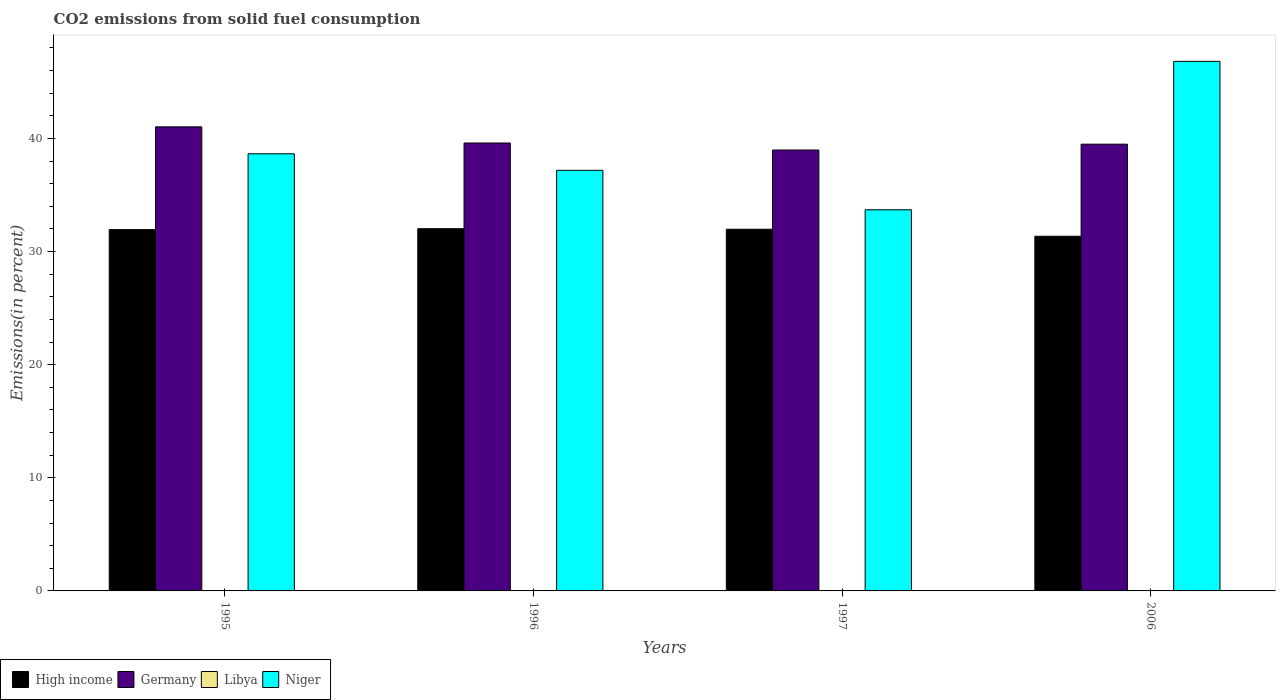How many different coloured bars are there?
Your response must be concise. 4. Are the number of bars on each tick of the X-axis equal?
Make the answer very short. Yes. How many bars are there on the 3rd tick from the left?
Give a very brief answer. 4. How many bars are there on the 3rd tick from the right?
Give a very brief answer. 4. In how many cases, is the number of bars for a given year not equal to the number of legend labels?
Offer a very short reply. 0. What is the total CO2 emitted in Niger in 1997?
Your response must be concise. 33.7. Across all years, what is the maximum total CO2 emitted in Niger?
Your answer should be compact. 46.82. Across all years, what is the minimum total CO2 emitted in Libya?
Make the answer very short. 0.01. What is the total total CO2 emitted in Libya in the graph?
Give a very brief answer. 0.1. What is the difference between the total CO2 emitted in Niger in 1997 and that in 2006?
Provide a succinct answer. -13.12. What is the difference between the total CO2 emitted in Niger in 2006 and the total CO2 emitted in Libya in 1995?
Make the answer very short. 46.79. What is the average total CO2 emitted in Germany per year?
Your response must be concise. 39.78. In the year 1996, what is the difference between the total CO2 emitted in Niger and total CO2 emitted in Germany?
Provide a short and direct response. -2.42. What is the ratio of the total CO2 emitted in High income in 1997 to that in 2006?
Ensure brevity in your answer.  1.02. Is the difference between the total CO2 emitted in Niger in 1995 and 1997 greater than the difference between the total CO2 emitted in Germany in 1995 and 1997?
Your answer should be very brief. Yes. What is the difference between the highest and the second highest total CO2 emitted in High income?
Offer a terse response. 0.05. What is the difference between the highest and the lowest total CO2 emitted in Libya?
Your answer should be very brief. 0.03. In how many years, is the total CO2 emitted in Germany greater than the average total CO2 emitted in Germany taken over all years?
Keep it short and to the point. 1. Is it the case that in every year, the sum of the total CO2 emitted in Libya and total CO2 emitted in High income is greater than the sum of total CO2 emitted in Niger and total CO2 emitted in Germany?
Make the answer very short. No. What does the 4th bar from the left in 1995 represents?
Offer a very short reply. Niger. How many bars are there?
Your answer should be very brief. 16. How many years are there in the graph?
Your answer should be compact. 4. What is the difference between two consecutive major ticks on the Y-axis?
Offer a terse response. 10. Where does the legend appear in the graph?
Provide a succinct answer. Bottom left. What is the title of the graph?
Provide a short and direct response. CO2 emissions from solid fuel consumption. What is the label or title of the X-axis?
Provide a short and direct response. Years. What is the label or title of the Y-axis?
Keep it short and to the point. Emissions(in percent). What is the Emissions(in percent) of High income in 1995?
Offer a very short reply. 31.94. What is the Emissions(in percent) of Germany in 1995?
Your answer should be compact. 41.03. What is the Emissions(in percent) in Libya in 1995?
Offer a very short reply. 0.03. What is the Emissions(in percent) in Niger in 1995?
Provide a succinct answer. 38.65. What is the Emissions(in percent) of High income in 1996?
Offer a very short reply. 32.02. What is the Emissions(in percent) of Germany in 1996?
Provide a short and direct response. 39.6. What is the Emissions(in percent) in Libya in 1996?
Your response must be concise. 0.03. What is the Emissions(in percent) of Niger in 1996?
Keep it short and to the point. 37.18. What is the Emissions(in percent) of High income in 1997?
Ensure brevity in your answer.  31.98. What is the Emissions(in percent) in Germany in 1997?
Offer a terse response. 38.98. What is the Emissions(in percent) in Libya in 1997?
Ensure brevity in your answer.  0.03. What is the Emissions(in percent) in Niger in 1997?
Offer a terse response. 33.7. What is the Emissions(in percent) in High income in 2006?
Give a very brief answer. 31.35. What is the Emissions(in percent) of Germany in 2006?
Keep it short and to the point. 39.5. What is the Emissions(in percent) of Libya in 2006?
Your answer should be compact. 0.01. What is the Emissions(in percent) in Niger in 2006?
Your response must be concise. 46.82. Across all years, what is the maximum Emissions(in percent) of High income?
Provide a short and direct response. 32.02. Across all years, what is the maximum Emissions(in percent) of Germany?
Offer a terse response. 41.03. Across all years, what is the maximum Emissions(in percent) in Libya?
Keep it short and to the point. 0.03. Across all years, what is the maximum Emissions(in percent) of Niger?
Offer a terse response. 46.82. Across all years, what is the minimum Emissions(in percent) in High income?
Offer a terse response. 31.35. Across all years, what is the minimum Emissions(in percent) of Germany?
Provide a succinct answer. 38.98. Across all years, what is the minimum Emissions(in percent) in Libya?
Your answer should be compact. 0.01. Across all years, what is the minimum Emissions(in percent) in Niger?
Your answer should be compact. 33.7. What is the total Emissions(in percent) of High income in the graph?
Make the answer very short. 127.3. What is the total Emissions(in percent) in Germany in the graph?
Provide a succinct answer. 159.1. What is the total Emissions(in percent) of Libya in the graph?
Provide a short and direct response. 0.1. What is the total Emissions(in percent) of Niger in the graph?
Give a very brief answer. 156.34. What is the difference between the Emissions(in percent) in High income in 1995 and that in 1996?
Offer a very short reply. -0.08. What is the difference between the Emissions(in percent) in Germany in 1995 and that in 1996?
Provide a short and direct response. 1.43. What is the difference between the Emissions(in percent) of Libya in 1995 and that in 1996?
Give a very brief answer. -0. What is the difference between the Emissions(in percent) in Niger in 1995 and that in 1996?
Your answer should be very brief. 1.46. What is the difference between the Emissions(in percent) in High income in 1995 and that in 1997?
Your answer should be very brief. -0.03. What is the difference between the Emissions(in percent) in Germany in 1995 and that in 1997?
Ensure brevity in your answer.  2.05. What is the difference between the Emissions(in percent) of Libya in 1995 and that in 1997?
Keep it short and to the point. -0. What is the difference between the Emissions(in percent) in Niger in 1995 and that in 1997?
Keep it short and to the point. 4.95. What is the difference between the Emissions(in percent) of High income in 1995 and that in 2006?
Your answer should be very brief. 0.59. What is the difference between the Emissions(in percent) in Germany in 1995 and that in 2006?
Provide a succinct answer. 1.53. What is the difference between the Emissions(in percent) of Libya in 1995 and that in 2006?
Offer a very short reply. 0.03. What is the difference between the Emissions(in percent) in Niger in 1995 and that in 2006?
Provide a succinct answer. -8.17. What is the difference between the Emissions(in percent) of High income in 1996 and that in 1997?
Offer a terse response. 0.05. What is the difference between the Emissions(in percent) in Germany in 1996 and that in 1997?
Make the answer very short. 0.62. What is the difference between the Emissions(in percent) in Libya in 1996 and that in 1997?
Make the answer very short. 0. What is the difference between the Emissions(in percent) in Niger in 1996 and that in 1997?
Your answer should be compact. 3.49. What is the difference between the Emissions(in percent) in High income in 1996 and that in 2006?
Give a very brief answer. 0.67. What is the difference between the Emissions(in percent) in Germany in 1996 and that in 2006?
Offer a terse response. 0.1. What is the difference between the Emissions(in percent) in Libya in 1996 and that in 2006?
Your response must be concise. 0.03. What is the difference between the Emissions(in percent) of Niger in 1996 and that in 2006?
Provide a succinct answer. -9.63. What is the difference between the Emissions(in percent) of High income in 1997 and that in 2006?
Offer a terse response. 0.62. What is the difference between the Emissions(in percent) of Germany in 1997 and that in 2006?
Keep it short and to the point. -0.52. What is the difference between the Emissions(in percent) of Libya in 1997 and that in 2006?
Offer a terse response. 0.03. What is the difference between the Emissions(in percent) in Niger in 1997 and that in 2006?
Make the answer very short. -13.12. What is the difference between the Emissions(in percent) in High income in 1995 and the Emissions(in percent) in Germany in 1996?
Give a very brief answer. -7.66. What is the difference between the Emissions(in percent) of High income in 1995 and the Emissions(in percent) of Libya in 1996?
Provide a succinct answer. 31.91. What is the difference between the Emissions(in percent) in High income in 1995 and the Emissions(in percent) in Niger in 1996?
Provide a short and direct response. -5.24. What is the difference between the Emissions(in percent) of Germany in 1995 and the Emissions(in percent) of Libya in 1996?
Provide a succinct answer. 40.99. What is the difference between the Emissions(in percent) of Germany in 1995 and the Emissions(in percent) of Niger in 1996?
Ensure brevity in your answer.  3.84. What is the difference between the Emissions(in percent) in Libya in 1995 and the Emissions(in percent) in Niger in 1996?
Give a very brief answer. -37.15. What is the difference between the Emissions(in percent) in High income in 1995 and the Emissions(in percent) in Germany in 1997?
Make the answer very short. -7.04. What is the difference between the Emissions(in percent) in High income in 1995 and the Emissions(in percent) in Libya in 1997?
Make the answer very short. 31.91. What is the difference between the Emissions(in percent) in High income in 1995 and the Emissions(in percent) in Niger in 1997?
Provide a short and direct response. -1.75. What is the difference between the Emissions(in percent) in Germany in 1995 and the Emissions(in percent) in Libya in 1997?
Ensure brevity in your answer.  41. What is the difference between the Emissions(in percent) of Germany in 1995 and the Emissions(in percent) of Niger in 1997?
Offer a very short reply. 7.33. What is the difference between the Emissions(in percent) of Libya in 1995 and the Emissions(in percent) of Niger in 1997?
Offer a very short reply. -33.66. What is the difference between the Emissions(in percent) in High income in 1995 and the Emissions(in percent) in Germany in 2006?
Your response must be concise. -7.55. What is the difference between the Emissions(in percent) of High income in 1995 and the Emissions(in percent) of Libya in 2006?
Your response must be concise. 31.94. What is the difference between the Emissions(in percent) in High income in 1995 and the Emissions(in percent) in Niger in 2006?
Your answer should be compact. -14.87. What is the difference between the Emissions(in percent) of Germany in 1995 and the Emissions(in percent) of Libya in 2006?
Offer a terse response. 41.02. What is the difference between the Emissions(in percent) in Germany in 1995 and the Emissions(in percent) in Niger in 2006?
Give a very brief answer. -5.79. What is the difference between the Emissions(in percent) in Libya in 1995 and the Emissions(in percent) in Niger in 2006?
Give a very brief answer. -46.79. What is the difference between the Emissions(in percent) in High income in 1996 and the Emissions(in percent) in Germany in 1997?
Your response must be concise. -6.96. What is the difference between the Emissions(in percent) in High income in 1996 and the Emissions(in percent) in Libya in 1997?
Provide a succinct answer. 31.99. What is the difference between the Emissions(in percent) in High income in 1996 and the Emissions(in percent) in Niger in 1997?
Offer a terse response. -1.67. What is the difference between the Emissions(in percent) in Germany in 1996 and the Emissions(in percent) in Libya in 1997?
Your response must be concise. 39.57. What is the difference between the Emissions(in percent) of Germany in 1996 and the Emissions(in percent) of Niger in 1997?
Ensure brevity in your answer.  5.9. What is the difference between the Emissions(in percent) in Libya in 1996 and the Emissions(in percent) in Niger in 1997?
Your response must be concise. -33.66. What is the difference between the Emissions(in percent) in High income in 1996 and the Emissions(in percent) in Germany in 2006?
Make the answer very short. -7.47. What is the difference between the Emissions(in percent) in High income in 1996 and the Emissions(in percent) in Libya in 2006?
Provide a succinct answer. 32.02. What is the difference between the Emissions(in percent) in High income in 1996 and the Emissions(in percent) in Niger in 2006?
Give a very brief answer. -14.79. What is the difference between the Emissions(in percent) in Germany in 1996 and the Emissions(in percent) in Libya in 2006?
Provide a short and direct response. 39.59. What is the difference between the Emissions(in percent) of Germany in 1996 and the Emissions(in percent) of Niger in 2006?
Provide a short and direct response. -7.22. What is the difference between the Emissions(in percent) of Libya in 1996 and the Emissions(in percent) of Niger in 2006?
Your answer should be very brief. -46.78. What is the difference between the Emissions(in percent) in High income in 1997 and the Emissions(in percent) in Germany in 2006?
Your response must be concise. -7.52. What is the difference between the Emissions(in percent) in High income in 1997 and the Emissions(in percent) in Libya in 2006?
Your answer should be very brief. 31.97. What is the difference between the Emissions(in percent) of High income in 1997 and the Emissions(in percent) of Niger in 2006?
Your answer should be compact. -14.84. What is the difference between the Emissions(in percent) in Germany in 1997 and the Emissions(in percent) in Libya in 2006?
Offer a terse response. 38.97. What is the difference between the Emissions(in percent) in Germany in 1997 and the Emissions(in percent) in Niger in 2006?
Offer a very short reply. -7.84. What is the difference between the Emissions(in percent) of Libya in 1997 and the Emissions(in percent) of Niger in 2006?
Provide a short and direct response. -46.79. What is the average Emissions(in percent) in High income per year?
Your answer should be very brief. 31.82. What is the average Emissions(in percent) in Germany per year?
Offer a terse response. 39.78. What is the average Emissions(in percent) in Libya per year?
Keep it short and to the point. 0.03. What is the average Emissions(in percent) of Niger per year?
Offer a very short reply. 39.09. In the year 1995, what is the difference between the Emissions(in percent) of High income and Emissions(in percent) of Germany?
Your answer should be compact. -9.08. In the year 1995, what is the difference between the Emissions(in percent) in High income and Emissions(in percent) in Libya?
Keep it short and to the point. 31.91. In the year 1995, what is the difference between the Emissions(in percent) of High income and Emissions(in percent) of Niger?
Offer a terse response. -6.7. In the year 1995, what is the difference between the Emissions(in percent) of Germany and Emissions(in percent) of Libya?
Your answer should be very brief. 41. In the year 1995, what is the difference between the Emissions(in percent) of Germany and Emissions(in percent) of Niger?
Make the answer very short. 2.38. In the year 1995, what is the difference between the Emissions(in percent) in Libya and Emissions(in percent) in Niger?
Offer a very short reply. -38.61. In the year 1996, what is the difference between the Emissions(in percent) of High income and Emissions(in percent) of Germany?
Your answer should be compact. -7.58. In the year 1996, what is the difference between the Emissions(in percent) of High income and Emissions(in percent) of Libya?
Give a very brief answer. 31.99. In the year 1996, what is the difference between the Emissions(in percent) in High income and Emissions(in percent) in Niger?
Keep it short and to the point. -5.16. In the year 1996, what is the difference between the Emissions(in percent) of Germany and Emissions(in percent) of Libya?
Your answer should be very brief. 39.57. In the year 1996, what is the difference between the Emissions(in percent) in Germany and Emissions(in percent) in Niger?
Ensure brevity in your answer.  2.42. In the year 1996, what is the difference between the Emissions(in percent) of Libya and Emissions(in percent) of Niger?
Provide a succinct answer. -37.15. In the year 1997, what is the difference between the Emissions(in percent) of High income and Emissions(in percent) of Germany?
Make the answer very short. -7. In the year 1997, what is the difference between the Emissions(in percent) of High income and Emissions(in percent) of Libya?
Provide a short and direct response. 31.94. In the year 1997, what is the difference between the Emissions(in percent) in High income and Emissions(in percent) in Niger?
Give a very brief answer. -1.72. In the year 1997, what is the difference between the Emissions(in percent) of Germany and Emissions(in percent) of Libya?
Offer a very short reply. 38.95. In the year 1997, what is the difference between the Emissions(in percent) in Germany and Emissions(in percent) in Niger?
Provide a short and direct response. 5.28. In the year 1997, what is the difference between the Emissions(in percent) in Libya and Emissions(in percent) in Niger?
Make the answer very short. -33.66. In the year 2006, what is the difference between the Emissions(in percent) of High income and Emissions(in percent) of Germany?
Your response must be concise. -8.14. In the year 2006, what is the difference between the Emissions(in percent) in High income and Emissions(in percent) in Libya?
Provide a short and direct response. 31.35. In the year 2006, what is the difference between the Emissions(in percent) of High income and Emissions(in percent) of Niger?
Provide a succinct answer. -15.46. In the year 2006, what is the difference between the Emissions(in percent) of Germany and Emissions(in percent) of Libya?
Offer a very short reply. 39.49. In the year 2006, what is the difference between the Emissions(in percent) in Germany and Emissions(in percent) in Niger?
Ensure brevity in your answer.  -7.32. In the year 2006, what is the difference between the Emissions(in percent) of Libya and Emissions(in percent) of Niger?
Give a very brief answer. -46.81. What is the ratio of the Emissions(in percent) of High income in 1995 to that in 1996?
Provide a short and direct response. 1. What is the ratio of the Emissions(in percent) in Germany in 1995 to that in 1996?
Offer a very short reply. 1.04. What is the ratio of the Emissions(in percent) in Libya in 1995 to that in 1996?
Keep it short and to the point. 0.96. What is the ratio of the Emissions(in percent) in Niger in 1995 to that in 1996?
Give a very brief answer. 1.04. What is the ratio of the Emissions(in percent) in High income in 1995 to that in 1997?
Offer a terse response. 1. What is the ratio of the Emissions(in percent) of Germany in 1995 to that in 1997?
Your answer should be very brief. 1.05. What is the ratio of the Emissions(in percent) of Libya in 1995 to that in 1997?
Give a very brief answer. 0.98. What is the ratio of the Emissions(in percent) of Niger in 1995 to that in 1997?
Make the answer very short. 1.15. What is the ratio of the Emissions(in percent) in High income in 1995 to that in 2006?
Ensure brevity in your answer.  1.02. What is the ratio of the Emissions(in percent) in Germany in 1995 to that in 2006?
Make the answer very short. 1.04. What is the ratio of the Emissions(in percent) in Libya in 1995 to that in 2006?
Offer a terse response. 4.74. What is the ratio of the Emissions(in percent) of Niger in 1995 to that in 2006?
Your answer should be compact. 0.83. What is the ratio of the Emissions(in percent) of Germany in 1996 to that in 1997?
Ensure brevity in your answer.  1.02. What is the ratio of the Emissions(in percent) in Libya in 1996 to that in 1997?
Provide a short and direct response. 1.02. What is the ratio of the Emissions(in percent) in Niger in 1996 to that in 1997?
Keep it short and to the point. 1.1. What is the ratio of the Emissions(in percent) in High income in 1996 to that in 2006?
Give a very brief answer. 1.02. What is the ratio of the Emissions(in percent) in Germany in 1996 to that in 2006?
Provide a short and direct response. 1. What is the ratio of the Emissions(in percent) in Libya in 1996 to that in 2006?
Keep it short and to the point. 4.94. What is the ratio of the Emissions(in percent) of Niger in 1996 to that in 2006?
Keep it short and to the point. 0.79. What is the ratio of the Emissions(in percent) of High income in 1997 to that in 2006?
Offer a terse response. 1.02. What is the ratio of the Emissions(in percent) in Germany in 1997 to that in 2006?
Offer a terse response. 0.99. What is the ratio of the Emissions(in percent) in Libya in 1997 to that in 2006?
Your answer should be compact. 4.85. What is the ratio of the Emissions(in percent) of Niger in 1997 to that in 2006?
Your response must be concise. 0.72. What is the difference between the highest and the second highest Emissions(in percent) in High income?
Make the answer very short. 0.05. What is the difference between the highest and the second highest Emissions(in percent) in Germany?
Make the answer very short. 1.43. What is the difference between the highest and the second highest Emissions(in percent) in Libya?
Make the answer very short. 0. What is the difference between the highest and the second highest Emissions(in percent) of Niger?
Offer a very short reply. 8.17. What is the difference between the highest and the lowest Emissions(in percent) in High income?
Provide a succinct answer. 0.67. What is the difference between the highest and the lowest Emissions(in percent) in Germany?
Your answer should be compact. 2.05. What is the difference between the highest and the lowest Emissions(in percent) of Libya?
Keep it short and to the point. 0.03. What is the difference between the highest and the lowest Emissions(in percent) of Niger?
Provide a short and direct response. 13.12. 